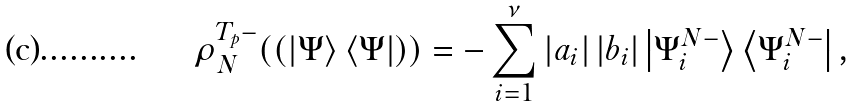<formula> <loc_0><loc_0><loc_500><loc_500>\rho _ { N } ^ { T _ { p } - } ( ( \left | \Psi \right \rangle \left \langle \Psi \right | ) ) = - \sum _ { i = 1 } ^ { \nu } \left | a _ { i } \right | \left | b _ { i } \right | \left | \Psi _ { i } ^ { N - } \right \rangle \left \langle \Psi _ { i } ^ { N - } \right | ,</formula> 